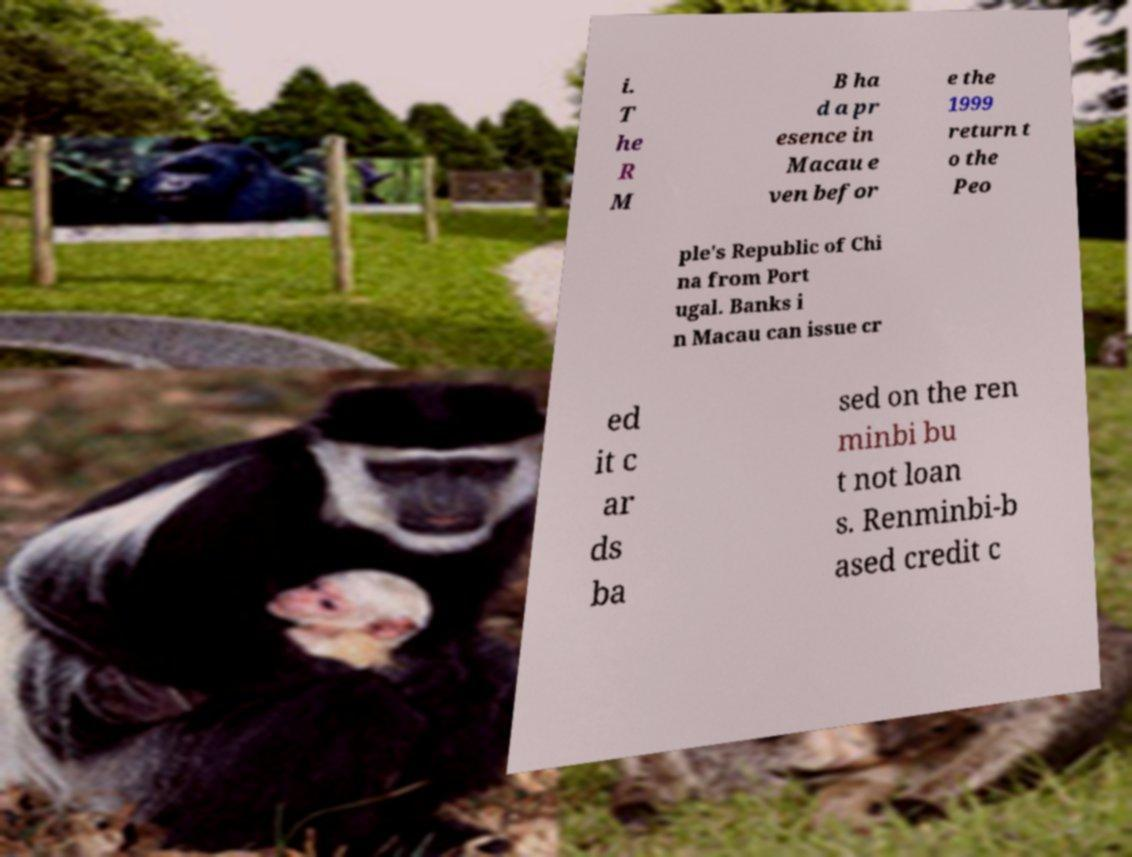Can you read and provide the text displayed in the image?This photo seems to have some interesting text. Can you extract and type it out for me? i. T he R M B ha d a pr esence in Macau e ven befor e the 1999 return t o the Peo ple's Republic of Chi na from Port ugal. Banks i n Macau can issue cr ed it c ar ds ba sed on the ren minbi bu t not loan s. Renminbi-b ased credit c 